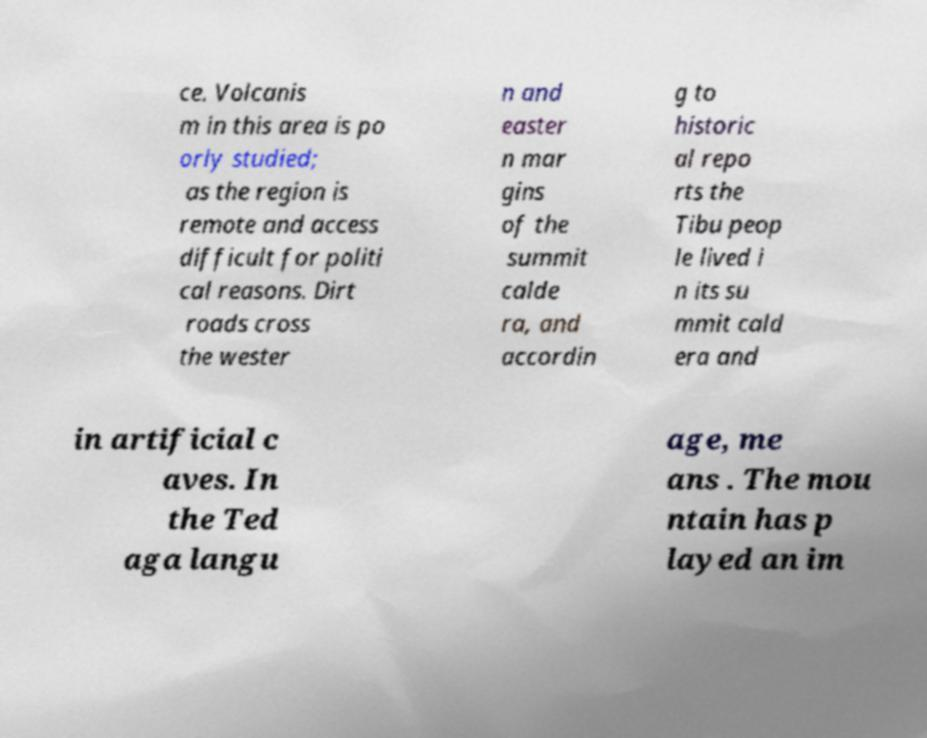There's text embedded in this image that I need extracted. Can you transcribe it verbatim? ce. Volcanis m in this area is po orly studied; as the region is remote and access difficult for politi cal reasons. Dirt roads cross the wester n and easter n mar gins of the summit calde ra, and accordin g to historic al repo rts the Tibu peop le lived i n its su mmit cald era and in artificial c aves. In the Ted aga langu age, me ans . The mou ntain has p layed an im 